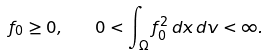Convert formula to latex. <formula><loc_0><loc_0><loc_500><loc_500>f _ { 0 } \geq 0 , \quad 0 < \int _ { \Omega } f _ { 0 } ^ { 2 } \, d x \, d v < \infty .</formula> 